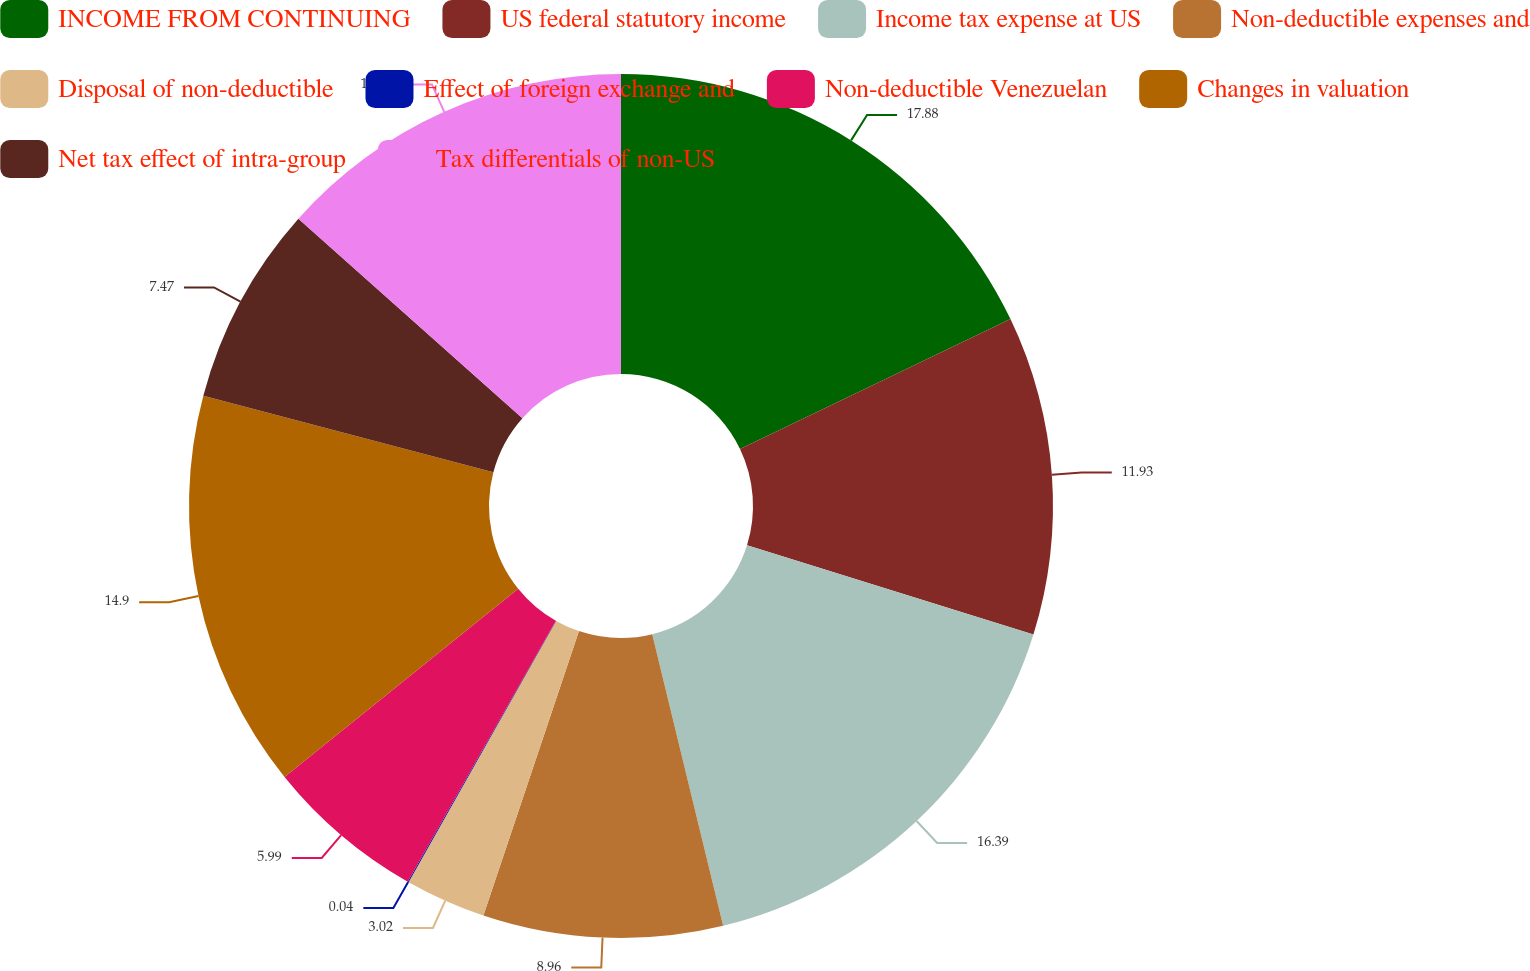<chart> <loc_0><loc_0><loc_500><loc_500><pie_chart><fcel>INCOME FROM CONTINUING<fcel>US federal statutory income<fcel>Income tax expense at US<fcel>Non-deductible expenses and<fcel>Disposal of non-deductible<fcel>Effect of foreign exchange and<fcel>Non-deductible Venezuelan<fcel>Changes in valuation<fcel>Net tax effect of intra-group<fcel>Tax differentials of non-US<nl><fcel>17.88%<fcel>11.93%<fcel>16.39%<fcel>8.96%<fcel>3.02%<fcel>0.04%<fcel>5.99%<fcel>14.9%<fcel>7.47%<fcel>13.42%<nl></chart> 